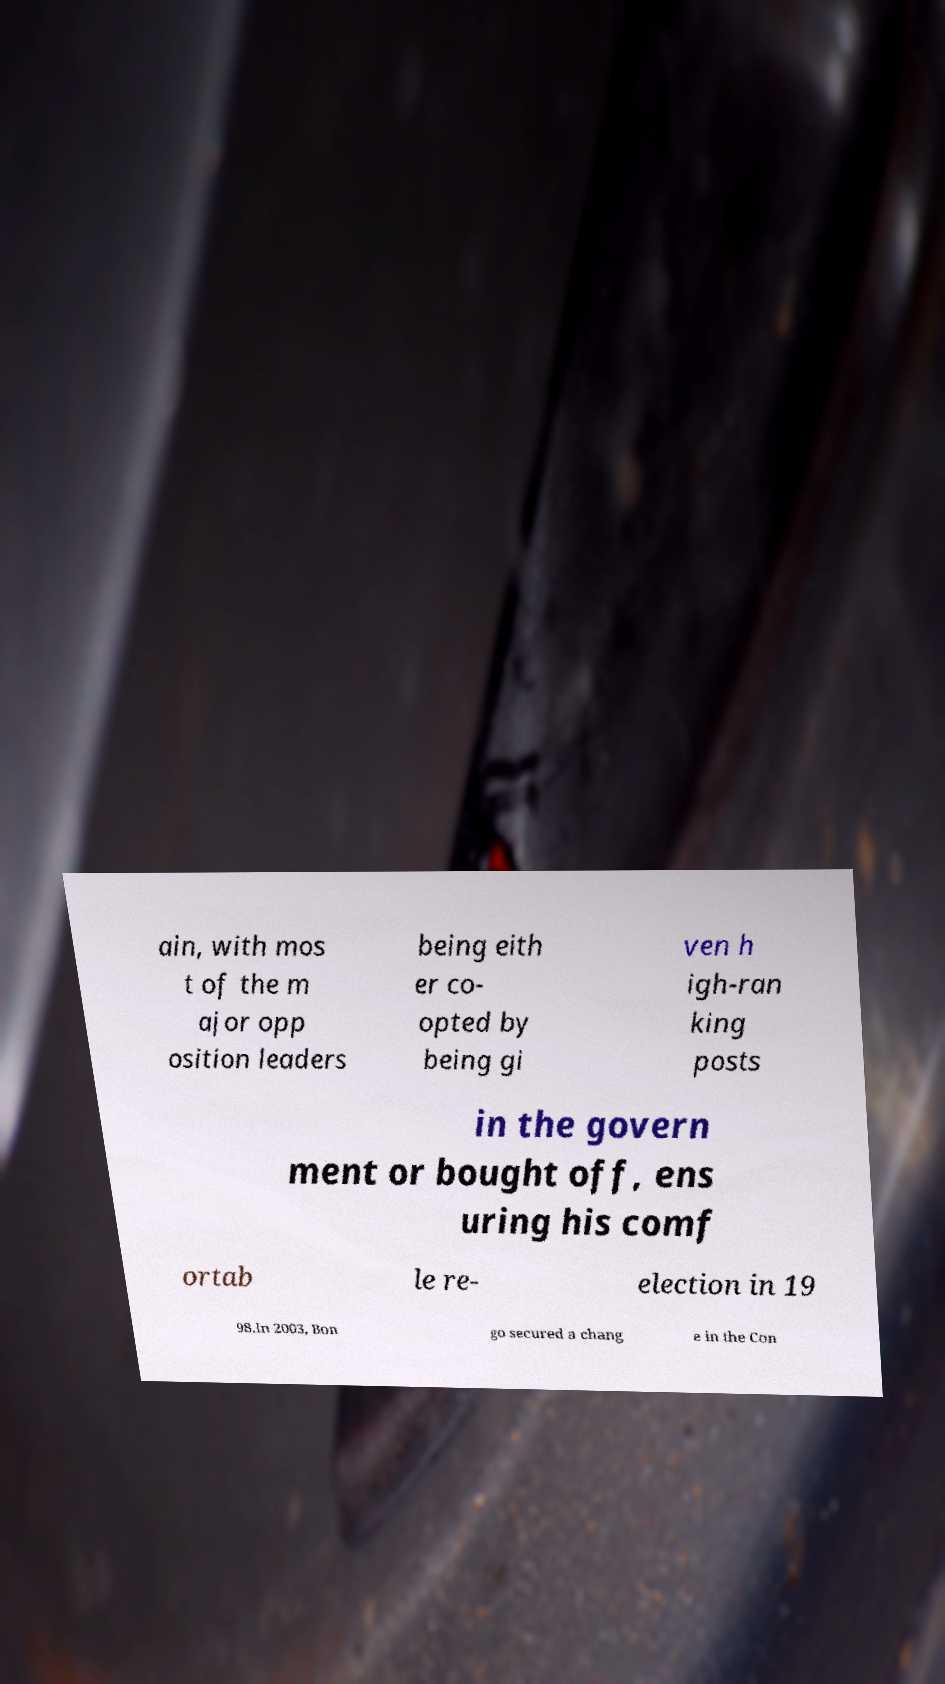Can you accurately transcribe the text from the provided image for me? ain, with mos t of the m ajor opp osition leaders being eith er co- opted by being gi ven h igh-ran king posts in the govern ment or bought off, ens uring his comf ortab le re- election in 19 98.In 2003, Bon go secured a chang e in the Con 